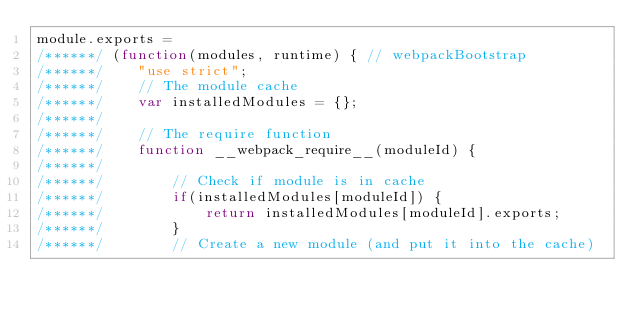Convert code to text. <code><loc_0><loc_0><loc_500><loc_500><_JavaScript_>module.exports =
/******/ (function(modules, runtime) { // webpackBootstrap
/******/ 	"use strict";
/******/ 	// The module cache
/******/ 	var installedModules = {};
/******/
/******/ 	// The require function
/******/ 	function __webpack_require__(moduleId) {
/******/
/******/ 		// Check if module is in cache
/******/ 		if(installedModules[moduleId]) {
/******/ 			return installedModules[moduleId].exports;
/******/ 		}
/******/ 		// Create a new module (and put it into the cache)</code> 